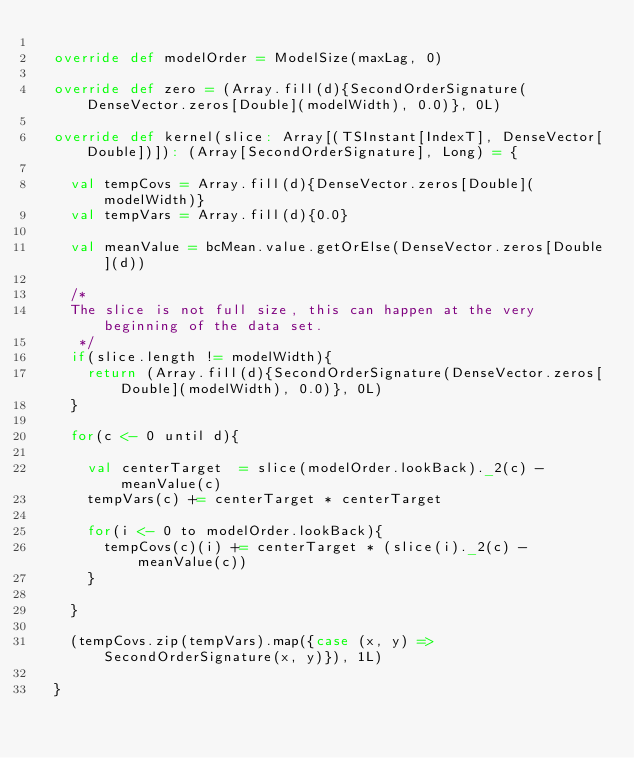<code> <loc_0><loc_0><loc_500><loc_500><_Scala_>
  override def modelOrder = ModelSize(maxLag, 0)

  override def zero = (Array.fill(d){SecondOrderSignature(DenseVector.zeros[Double](modelWidth), 0.0)}, 0L)

  override def kernel(slice: Array[(TSInstant[IndexT], DenseVector[Double])]): (Array[SecondOrderSignature], Long) = {

    val tempCovs = Array.fill(d){DenseVector.zeros[Double](modelWidth)}
    val tempVars = Array.fill(d){0.0}

    val meanValue = bcMean.value.getOrElse(DenseVector.zeros[Double](d))

    /*
    The slice is not full size, this can happen at the very beginning of the data set.
     */
    if(slice.length != modelWidth){
      return (Array.fill(d){SecondOrderSignature(DenseVector.zeros[Double](modelWidth), 0.0)}, 0L)
    }

    for(c <- 0 until d){

      val centerTarget  = slice(modelOrder.lookBack)._2(c) - meanValue(c)
      tempVars(c) += centerTarget * centerTarget

      for(i <- 0 to modelOrder.lookBack){
        tempCovs(c)(i) += centerTarget * (slice(i)._2(c) - meanValue(c))
      }

    }

    (tempCovs.zip(tempVars).map({case (x, y) => SecondOrderSignature(x, y)}), 1L)

  }
</code> 